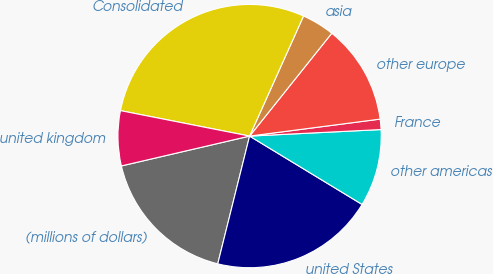Convert chart to OTSL. <chart><loc_0><loc_0><loc_500><loc_500><pie_chart><fcel>(millions of dollars)<fcel>united States<fcel>other americas<fcel>France<fcel>other europe<fcel>asia<fcel>Consolidated<fcel>united kingdom<nl><fcel>17.47%<fcel>20.2%<fcel>9.48%<fcel>1.27%<fcel>12.21%<fcel>4.01%<fcel>28.62%<fcel>6.74%<nl></chart> 